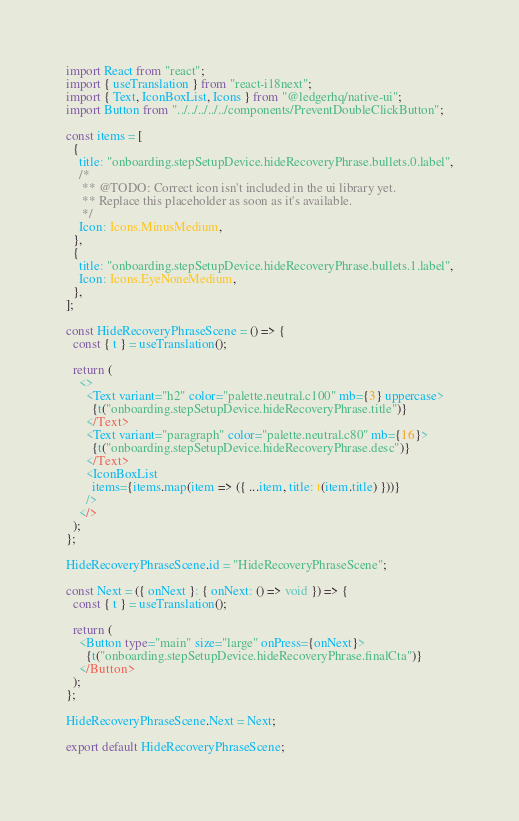Convert code to text. <code><loc_0><loc_0><loc_500><loc_500><_TypeScript_>import React from "react";
import { useTranslation } from "react-i18next";
import { Text, IconBoxList, Icons } from "@ledgerhq/native-ui";
import Button from "../../../../../components/PreventDoubleClickButton";

const items = [
  {
    title: "onboarding.stepSetupDevice.hideRecoveryPhrase.bullets.0.label",
    /*
     ** @TODO: Correct icon isn't included in the ui library yet.
     ** Replace this placeholder as soon as it's available.
     */
    Icon: Icons.MinusMedium,
  },
  {
    title: "onboarding.stepSetupDevice.hideRecoveryPhrase.bullets.1.label",
    Icon: Icons.EyeNoneMedium,
  },
];

const HideRecoveryPhraseScene = () => {
  const { t } = useTranslation();

  return (
    <>
      <Text variant="h2" color="palette.neutral.c100" mb={3} uppercase>
        {t("onboarding.stepSetupDevice.hideRecoveryPhrase.title")}
      </Text>
      <Text variant="paragraph" color="palette.neutral.c80" mb={16}>
        {t("onboarding.stepSetupDevice.hideRecoveryPhrase.desc")}
      </Text>
      <IconBoxList
        items={items.map(item => ({ ...item, title: t(item.title) }))}
      />
    </>
  );
};

HideRecoveryPhraseScene.id = "HideRecoveryPhraseScene";

const Next = ({ onNext }: { onNext: () => void }) => {
  const { t } = useTranslation();

  return (
    <Button type="main" size="large" onPress={onNext}>
      {t("onboarding.stepSetupDevice.hideRecoveryPhrase.finalCta")}
    </Button>
  );
};

HideRecoveryPhraseScene.Next = Next;

export default HideRecoveryPhraseScene;
</code> 